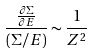<formula> <loc_0><loc_0><loc_500><loc_500>\ \frac { \frac { \partial \Sigma } { \partial E } } { ( \Sigma / E ) } \sim \frac { 1 } { Z ^ { 2 } }</formula> 